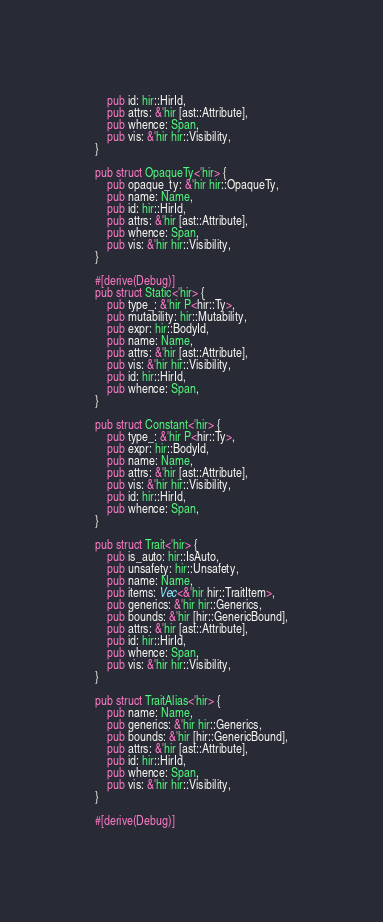Convert code to text. <code><loc_0><loc_0><loc_500><loc_500><_Rust_>    pub id: hir::HirId,
    pub attrs: &'hir [ast::Attribute],
    pub whence: Span,
    pub vis: &'hir hir::Visibility,
}

pub struct OpaqueTy<'hir> {
    pub opaque_ty: &'hir hir::OpaqueTy,
    pub name: Name,
    pub id: hir::HirId,
    pub attrs: &'hir [ast::Attribute],
    pub whence: Span,
    pub vis: &'hir hir::Visibility,
}

#[derive(Debug)]
pub struct Static<'hir> {
    pub type_: &'hir P<hir::Ty>,
    pub mutability: hir::Mutability,
    pub expr: hir::BodyId,
    pub name: Name,
    pub attrs: &'hir [ast::Attribute],
    pub vis: &'hir hir::Visibility,
    pub id: hir::HirId,
    pub whence: Span,
}

pub struct Constant<'hir> {
    pub type_: &'hir P<hir::Ty>,
    pub expr: hir::BodyId,
    pub name: Name,
    pub attrs: &'hir [ast::Attribute],
    pub vis: &'hir hir::Visibility,
    pub id: hir::HirId,
    pub whence: Span,
}

pub struct Trait<'hir> {
    pub is_auto: hir::IsAuto,
    pub unsafety: hir::Unsafety,
    pub name: Name,
    pub items: Vec<&'hir hir::TraitItem>,
    pub generics: &'hir hir::Generics,
    pub bounds: &'hir [hir::GenericBound],
    pub attrs: &'hir [ast::Attribute],
    pub id: hir::HirId,
    pub whence: Span,
    pub vis: &'hir hir::Visibility,
}

pub struct TraitAlias<'hir> {
    pub name: Name,
    pub generics: &'hir hir::Generics,
    pub bounds: &'hir [hir::GenericBound],
    pub attrs: &'hir [ast::Attribute],
    pub id: hir::HirId,
    pub whence: Span,
    pub vis: &'hir hir::Visibility,
}

#[derive(Debug)]</code> 